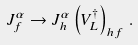Convert formula to latex. <formula><loc_0><loc_0><loc_500><loc_500>J _ { f } ^ { \alpha } \rightarrow J _ { h } ^ { \alpha } \left ( V _ { L } ^ { \dagger } \right ) _ { h f } \, .</formula> 